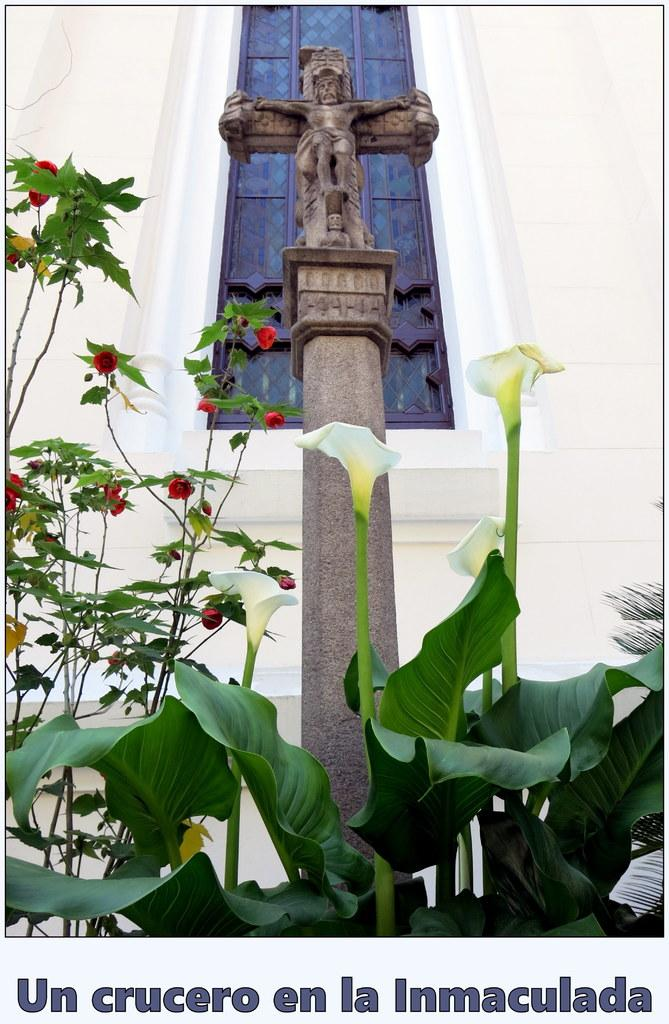What type of visual is shown in the image? The image appears to be a poster. What is the main subject of the poster? There is a building depicted in the poster. What other elements are present in the poster? There are plants with flowers and a memorial in the poster. Is there any text on the poster? Yes, text is present at the bottom of the poster. What type of dinner is being served at the memorial in the poster? There is no dinner depicted in the poster; it only shows a building, plants with flowers, and a memorial. Can you describe the sweater worn by the person standing next to the memorial? There is no person shown in the poster, so it is not possible to describe any clothing they might be wearing. 